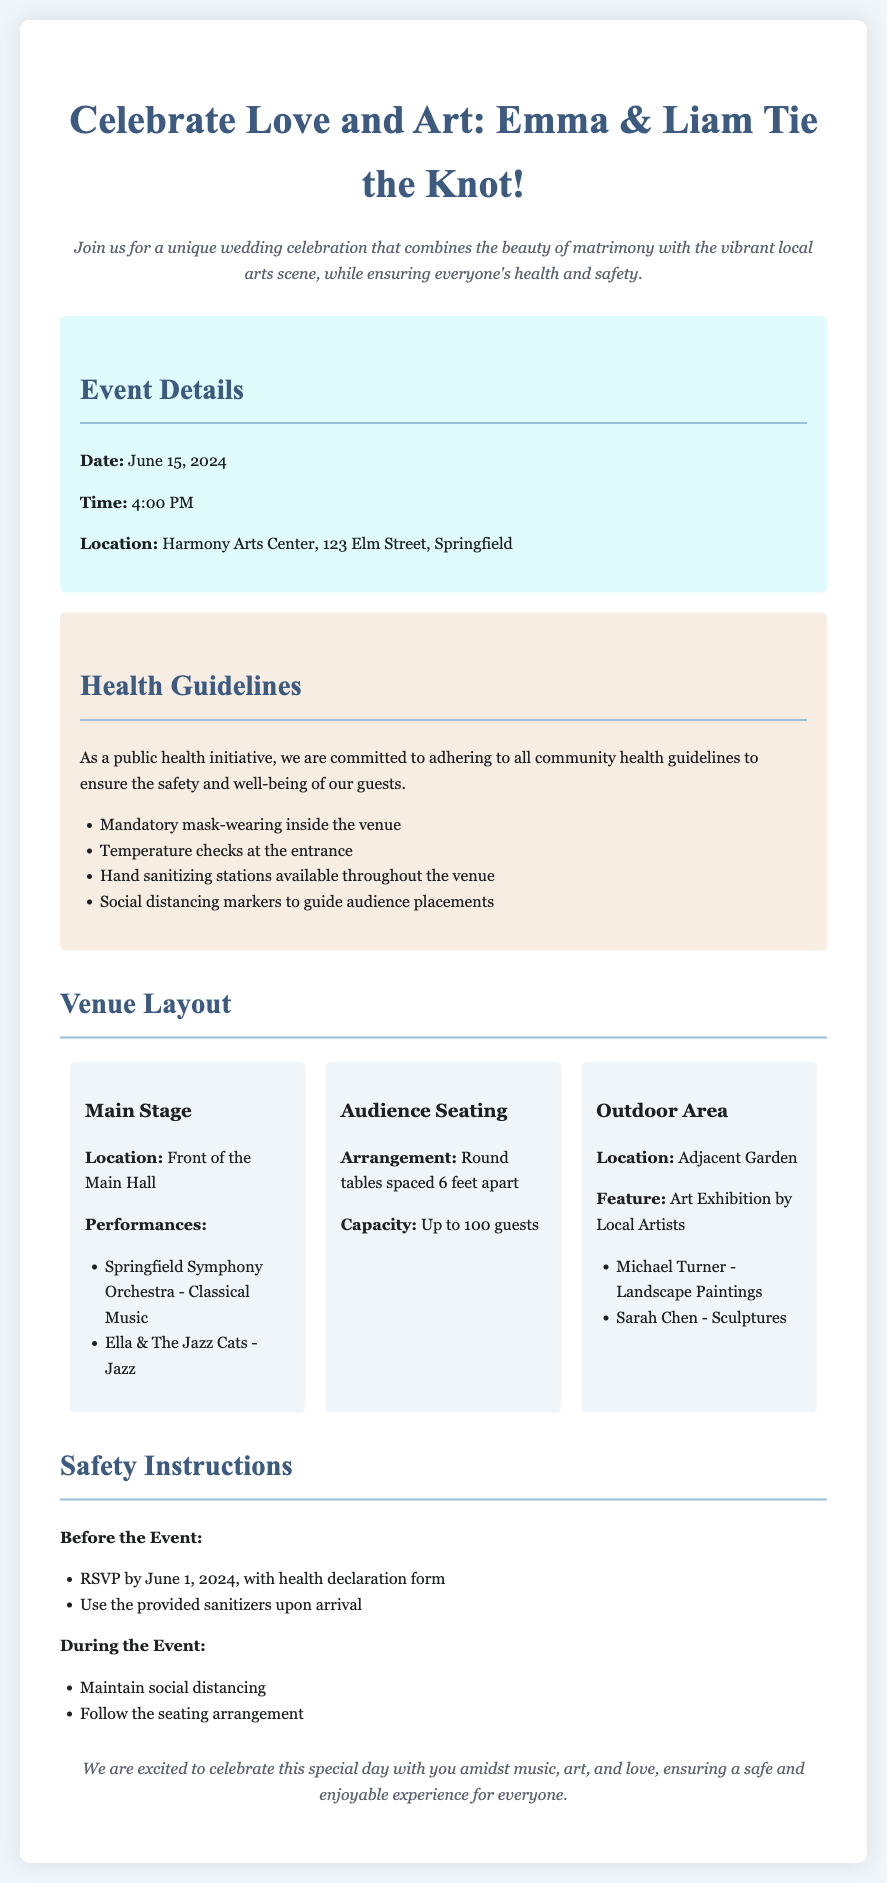What is the date of the wedding celebration? The date of the wedding celebration is mentioned directly in the event details section.
Answer: June 15, 2024 What is the location of the event? The location of the event is specified in the event details section of the document.
Answer: Harmony Arts Center, 123 Elm Street, Springfield How many guests can the venue accommodate? The capacity for guests is given in the audience seating section of the document.
Answer: Up to 100 guests What performances are listed for the Main Stage? The performances scheduled on the Main Stage are provided in the venue layout section of the document.
Answer: Springfield Symphony Orchestra - Classical Music, Ella & The Jazz Cats - Jazz What safety measure is taken at the entrance? The specific safety measure at the entrance is mentioned in the health guidelines section of the document.
Answer: Temperature checks Why are social distancing markers present? The reason for social distancing markers is implied based on the commitment to public health guidelines in the document.
Answer: To guide audience placements What type of art exhibition is featured in the outdoor area? The type of exhibition is indicated in the outdoor area section of the venue layout.
Answer: Art Exhibition by Local Artists What is required to attend the event? The requirements to attend the event are listed under safety instructions, indicating what guests must do beforehand.
Answer: RSVP by June 1, 2024, with health declaration form 